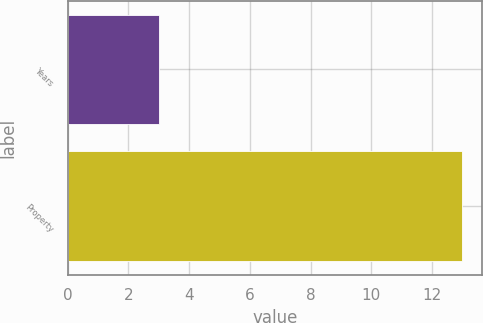<chart> <loc_0><loc_0><loc_500><loc_500><bar_chart><fcel>Years<fcel>Property<nl><fcel>3<fcel>13<nl></chart> 